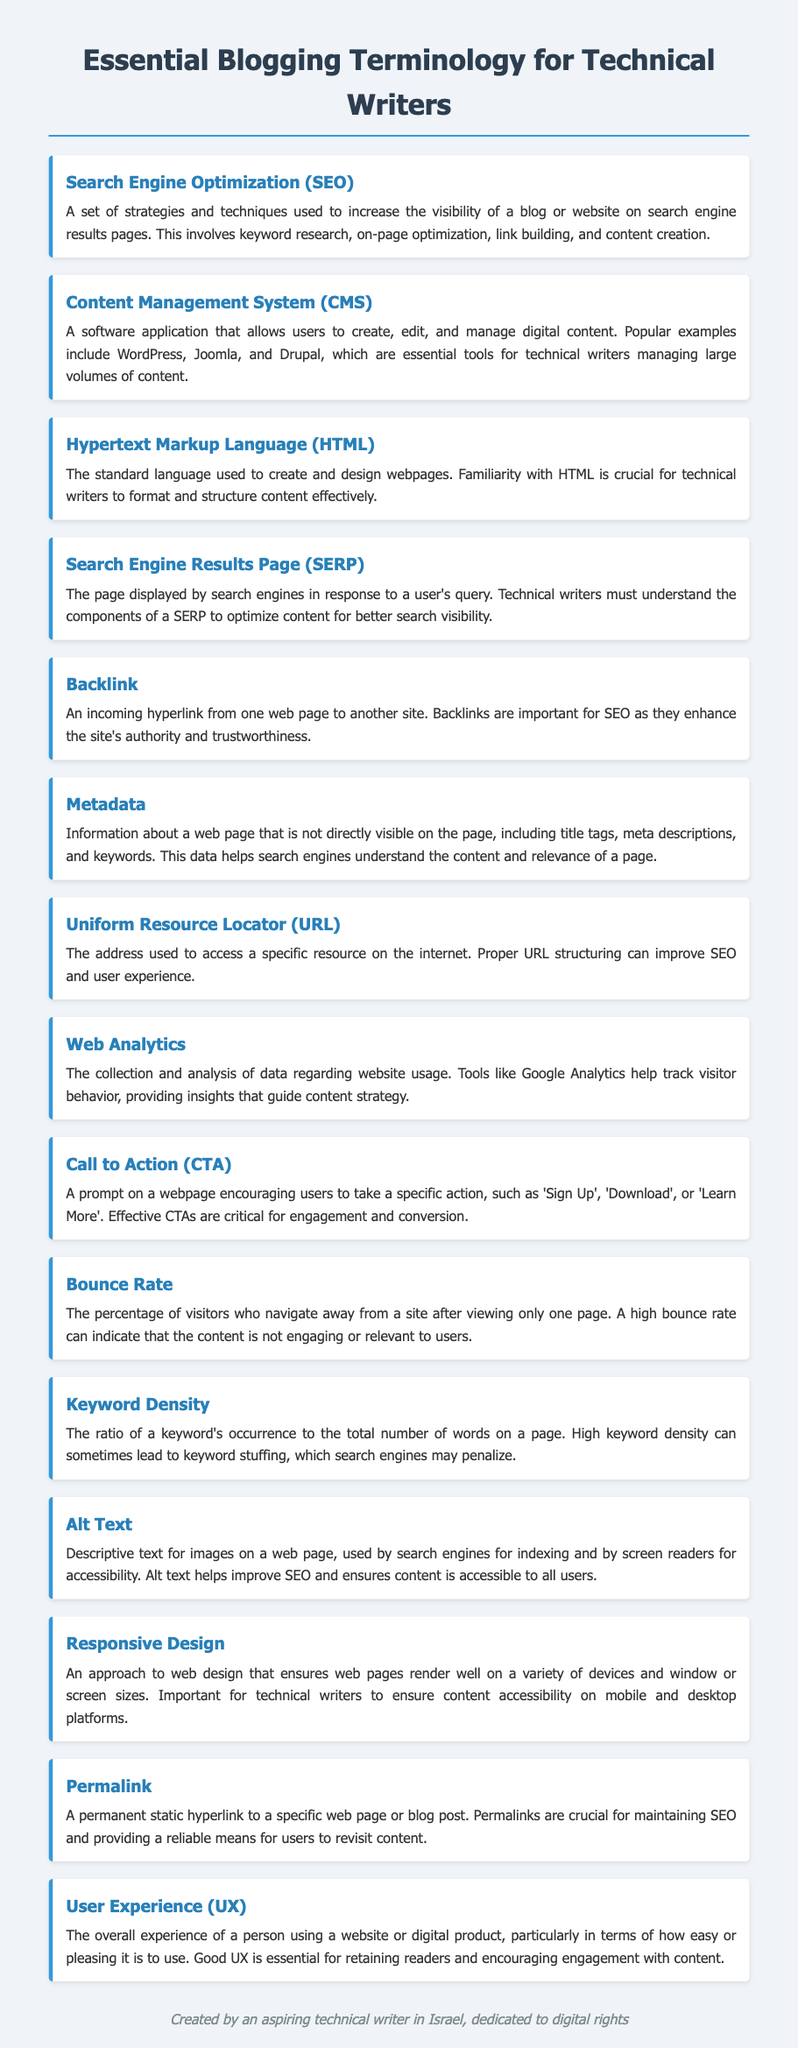what does SEO stand for? SEO is an abbreviation found in the document, standing for Search Engine Optimization.
Answer: Search Engine Optimization what is a CMS? The document defines a CMS as a software application that allows users to create, edit, and manage digital content.
Answer: Content Management System what is the primary function of HTML? The document states that HTML is used to create and design webpages, which is important for technical writers.
Answer: Create and design webpages what is a permalink? A permalink is described in the document as a permanent static hyperlink to a specific web page or blog post.
Answer: Permanent static hyperlink what does UX stand for? UX is an abbreviation mentioned in the document, standing for User Experience.
Answer: User Experience why are backlinks important for SEO? The document explains that backlinks enhance a site's authority and trustworthiness, which are crucial for SEO.
Answer: Enhance authority and trustworthiness what does high keyword density potentially lead to? The document suggests that high keyword density can lead to keyword stuffing, which may attract penalties from search engines.
Answer: Keyword stuffing what is the purpose of alt text? The document states that alt text is used for indexing by search engines and ensuring accessibility for screen readers.
Answer: Indexing and accessibility what can a high bounce rate indicate? The document mentions that a high bounce rate may indicate the content is not engaging or relevant to users.
Answer: Not engaging or relevant content 